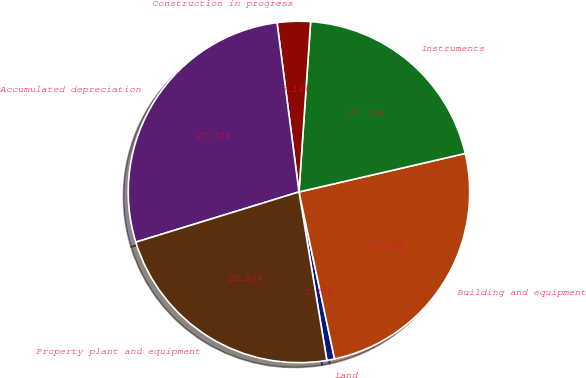<chart> <loc_0><loc_0><loc_500><loc_500><pie_chart><fcel>Land<fcel>Building and equipment<fcel>Instruments<fcel>Construction in progress<fcel>Accumulated depreciation<fcel>Property plant and equipment<nl><fcel>0.73%<fcel>25.28%<fcel>20.29%<fcel>3.14%<fcel>27.7%<fcel>22.86%<nl></chart> 